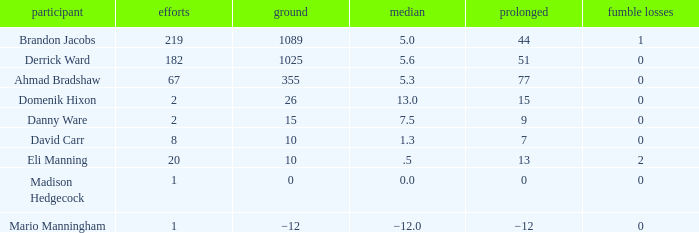What is Domenik Hixon's average rush? 13.0. 